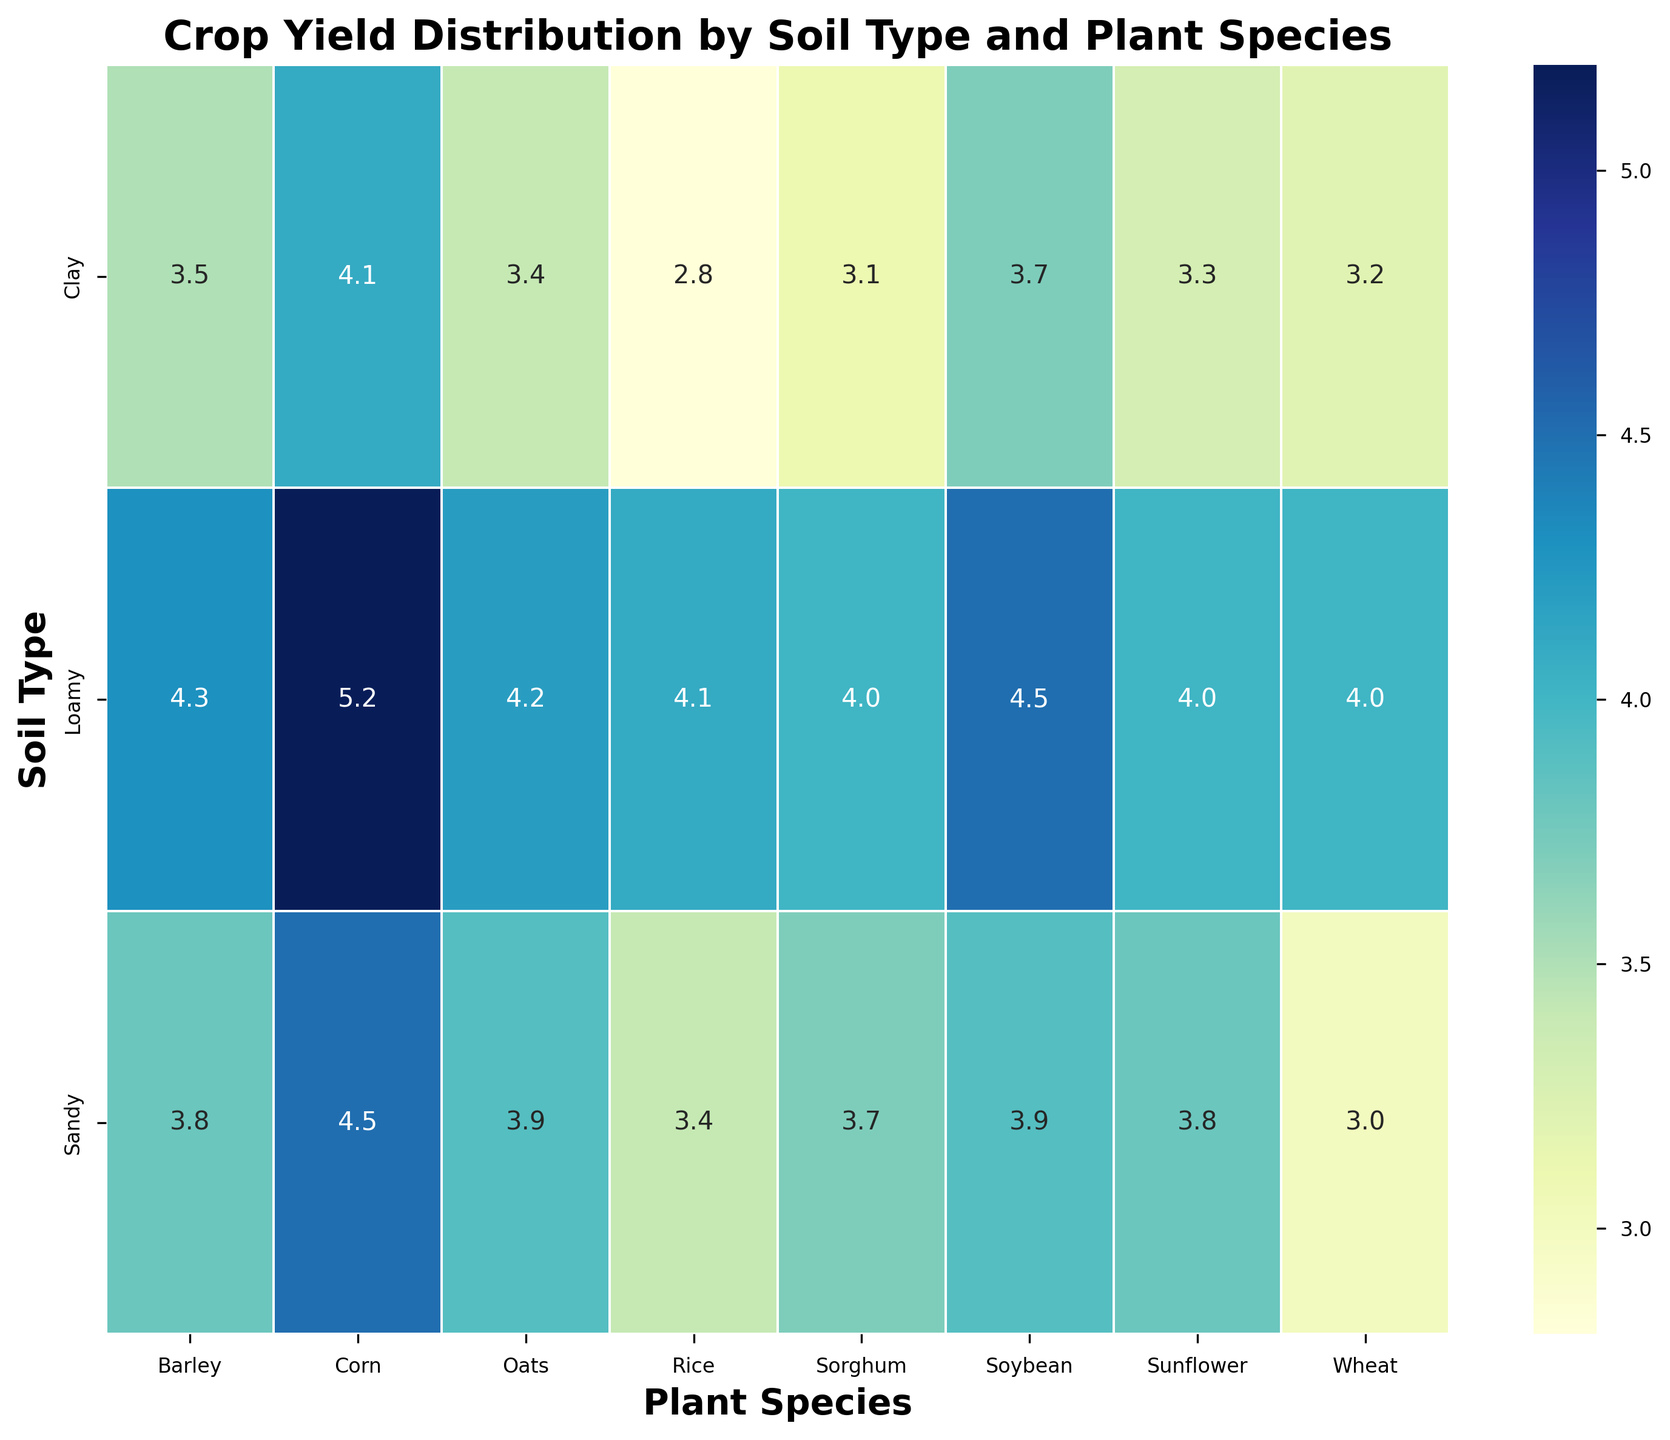What's the overall highest crop yield shown for the different plant species? The highest crop yield can be found by visually inspecting the annotated values on the heatmap and identifying the maximum value. The highest crop yield is 5.2 for Corn on Loamy soil.
Answer: 5.2 Which soil type has the highest average crop yield across all plant species? To find this, calculate the average crop yield for each soil type: 
Clay: (3.2+4.1+3.7+2.8+3.5+3.1+3.4+3.3)/8 = 3.39, 
Sandy: (3.0+4.5+3.9+3.4+3.8+3.7+3.9+3.8)/8 = 3.88, 
Loamy: (4.0+5.2+4.5+4.1+4.3+4.0+4.2+4.0)/8 = 4.16.
Loamy soil has the highest average crop yield.
Answer: Loamy Which plant species yields more in Sandy soil, Corn or Soybean? Refer to the heatmap and compare the crop yields of Corn and Soybean in Sandy soil. Corn has a yield of 4.5, and Soybean has a yield of 3.9. Corn yields more.
Answer: Corn Is there any observed plant species that has same crop yield across all soil types? Check each plant species's crop yield across all soil types visually on the heatmap. No plant species has the same crop yield across all soil types.
Answer: No Which plant species has the most variation in crop yield across different soil types? To find this, calculate the range (max crop yield - min crop yield) for each plant species:
Wheat: 4.0-3.0, Corn: 5.2-4.1, Soybean: 4.5-3.7, Rice: 4.1-2.8, Barley: 4.3-3.5, Sorghum: 4.0-3.1, Oats: 4.2-3.4, Sunflower: 4.0-3.3.
Rice has the highest range of 4.1-2.8 = 1.3.
Answer: Rice On which soil type does Barley perform the best? Find the highest crop yield for Barley on the heatmap, which is seen in Loamy soil with a yield of 4.3.
Answer: Loamy If we mix the yields of Wheat and Rice, which soil type gives the highest combined yield? Calculate the combined yield for Wheat and Rice for each soil type:
Clay: 3.2 + 2.8 = 6.0,
Sandy: 3.0 + 3.4 = 6.4,
Loamy: 4.0 + 4.1 = 8.1.
Loamy soil gives the highest combined yield.
Answer: Loamy What's the average yield for Soybean across all soil types? Sum the yields of Soybean across all soil types and then divide by three: (3.7 + 3.9 + 4.5)/3 = 4.03.
Answer: 4.03 